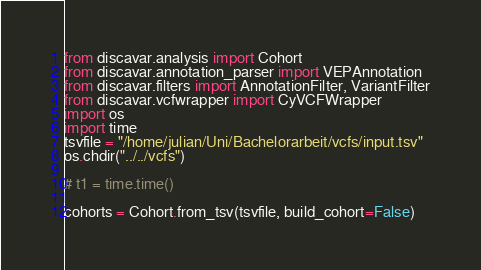Convert code to text. <code><loc_0><loc_0><loc_500><loc_500><_Python_>from discavar.analysis import Cohort
from discavar.annotation_parser import VEPAnnotation
from discavar.filters import AnnotationFilter, VariantFilter
from discavar.vcfwrapper import CyVCFWrapper
import os
import time
tsvfile = "/home/julian/Uni/Bachelorarbeit/vcfs/input.tsv"
os.chdir("../../vcfs")

# t1 = time.time()

cohorts = Cohort.from_tsv(tsvfile, build_cohort=False)</code> 